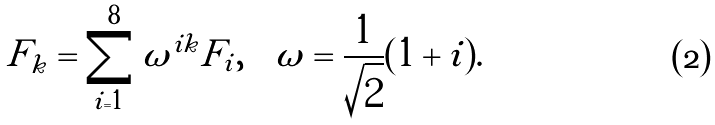<formula> <loc_0><loc_0><loc_500><loc_500>\tilde { F } _ { k } = \sum _ { i = 1 } ^ { 8 } \omega ^ { i k } F _ { i } , \quad \omega = \frac { 1 } { \sqrt { 2 } } ( 1 + i ) .</formula> 